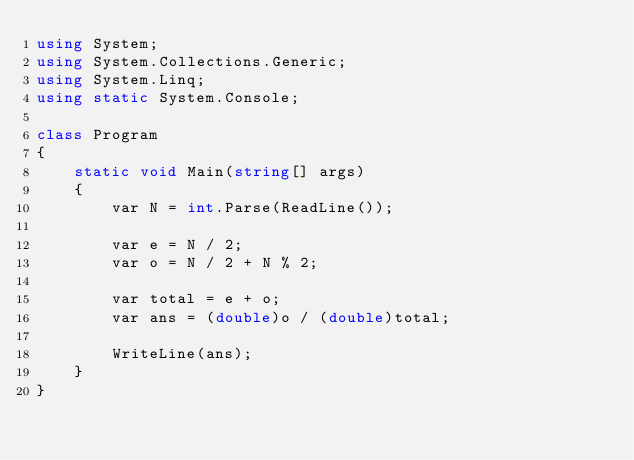<code> <loc_0><loc_0><loc_500><loc_500><_C#_>using System;
using System.Collections.Generic;
using System.Linq;
using static System.Console;

class Program
{
    static void Main(string[] args)
    {
        var N = int.Parse(ReadLine());

        var e = N / 2;
        var o = N / 2 + N % 2;

        var total = e + o;
        var ans = (double)o / (double)total;

        WriteLine(ans);
    }
}
</code> 